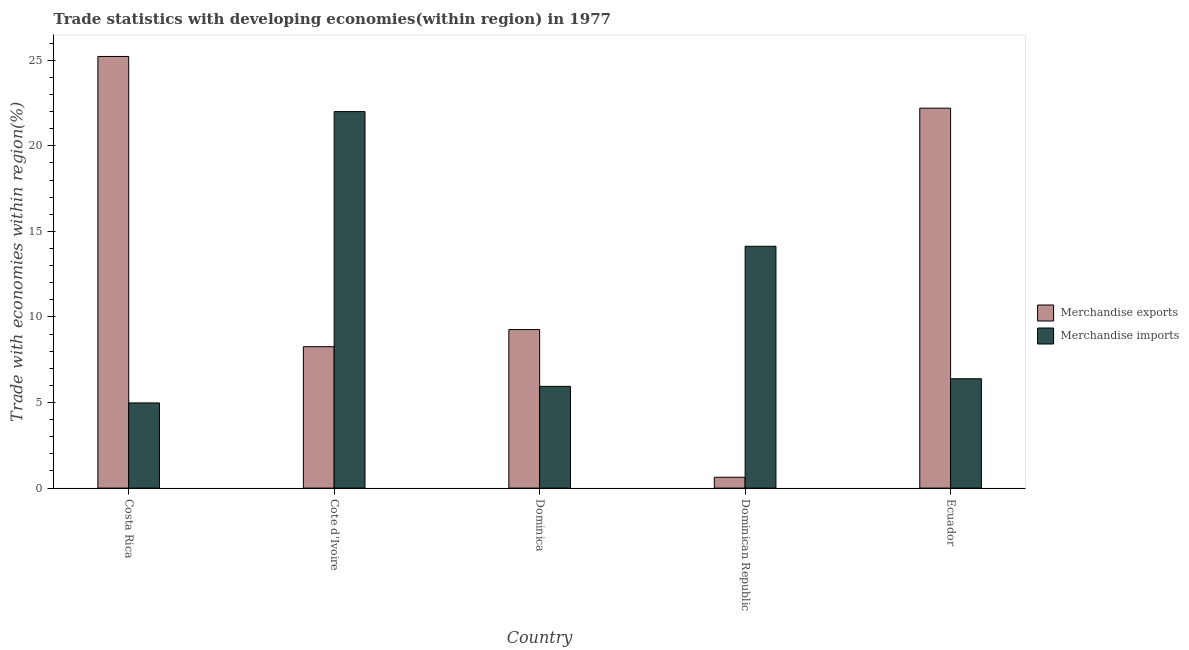Are the number of bars per tick equal to the number of legend labels?
Keep it short and to the point. Yes. Are the number of bars on each tick of the X-axis equal?
Offer a terse response. Yes. What is the label of the 3rd group of bars from the left?
Ensure brevity in your answer.  Dominica. In how many cases, is the number of bars for a given country not equal to the number of legend labels?
Your answer should be compact. 0. What is the merchandise exports in Cote d'Ivoire?
Your response must be concise. 8.26. Across all countries, what is the maximum merchandise exports?
Ensure brevity in your answer.  25.23. Across all countries, what is the minimum merchandise exports?
Keep it short and to the point. 0.63. In which country was the merchandise exports maximum?
Ensure brevity in your answer.  Costa Rica. In which country was the merchandise exports minimum?
Your response must be concise. Dominican Republic. What is the total merchandise imports in the graph?
Your answer should be compact. 53.45. What is the difference between the merchandise imports in Costa Rica and that in Cote d'Ivoire?
Give a very brief answer. -17.03. What is the difference between the merchandise exports in Cote d'Ivoire and the merchandise imports in Dominican Republic?
Offer a terse response. -5.87. What is the average merchandise imports per country?
Offer a very short reply. 10.69. What is the difference between the merchandise imports and merchandise exports in Cote d'Ivoire?
Provide a succinct answer. 13.74. In how many countries, is the merchandise exports greater than 20 %?
Your response must be concise. 2. What is the ratio of the merchandise imports in Costa Rica to that in Cote d'Ivoire?
Your answer should be compact. 0.23. Is the merchandise exports in Costa Rica less than that in Dominican Republic?
Your response must be concise. No. What is the difference between the highest and the second highest merchandise imports?
Make the answer very short. 7.87. What is the difference between the highest and the lowest merchandise exports?
Your answer should be very brief. 24.59. What does the 1st bar from the left in Dominica represents?
Make the answer very short. Merchandise exports. What does the 2nd bar from the right in Dominica represents?
Ensure brevity in your answer.  Merchandise exports. How many bars are there?
Your answer should be compact. 10. Are all the bars in the graph horizontal?
Your answer should be compact. No. How many countries are there in the graph?
Make the answer very short. 5. What is the difference between two consecutive major ticks on the Y-axis?
Give a very brief answer. 5. Does the graph contain any zero values?
Provide a short and direct response. No. What is the title of the graph?
Your answer should be very brief. Trade statistics with developing economies(within region) in 1977. Does "From production" appear as one of the legend labels in the graph?
Your response must be concise. No. What is the label or title of the X-axis?
Keep it short and to the point. Country. What is the label or title of the Y-axis?
Offer a terse response. Trade with economies within region(%). What is the Trade with economies within region(%) of Merchandise exports in Costa Rica?
Provide a succinct answer. 25.23. What is the Trade with economies within region(%) of Merchandise imports in Costa Rica?
Your answer should be very brief. 4.98. What is the Trade with economies within region(%) of Merchandise exports in Cote d'Ivoire?
Give a very brief answer. 8.26. What is the Trade with economies within region(%) in Merchandise imports in Cote d'Ivoire?
Your answer should be very brief. 22. What is the Trade with economies within region(%) of Merchandise exports in Dominica?
Keep it short and to the point. 9.26. What is the Trade with economies within region(%) in Merchandise imports in Dominica?
Provide a short and direct response. 5.95. What is the Trade with economies within region(%) in Merchandise exports in Dominican Republic?
Provide a short and direct response. 0.63. What is the Trade with economies within region(%) of Merchandise imports in Dominican Republic?
Give a very brief answer. 14.13. What is the Trade with economies within region(%) in Merchandise exports in Ecuador?
Ensure brevity in your answer.  22.2. What is the Trade with economies within region(%) in Merchandise imports in Ecuador?
Keep it short and to the point. 6.39. Across all countries, what is the maximum Trade with economies within region(%) of Merchandise exports?
Provide a succinct answer. 25.23. Across all countries, what is the maximum Trade with economies within region(%) of Merchandise imports?
Offer a terse response. 22. Across all countries, what is the minimum Trade with economies within region(%) of Merchandise exports?
Your answer should be very brief. 0.63. Across all countries, what is the minimum Trade with economies within region(%) in Merchandise imports?
Your answer should be very brief. 4.98. What is the total Trade with economies within region(%) in Merchandise exports in the graph?
Provide a short and direct response. 65.59. What is the total Trade with economies within region(%) of Merchandise imports in the graph?
Offer a very short reply. 53.45. What is the difference between the Trade with economies within region(%) of Merchandise exports in Costa Rica and that in Cote d'Ivoire?
Make the answer very short. 16.96. What is the difference between the Trade with economies within region(%) of Merchandise imports in Costa Rica and that in Cote d'Ivoire?
Make the answer very short. -17.03. What is the difference between the Trade with economies within region(%) of Merchandise exports in Costa Rica and that in Dominica?
Your response must be concise. 15.96. What is the difference between the Trade with economies within region(%) in Merchandise imports in Costa Rica and that in Dominica?
Your answer should be compact. -0.97. What is the difference between the Trade with economies within region(%) in Merchandise exports in Costa Rica and that in Dominican Republic?
Your answer should be very brief. 24.59. What is the difference between the Trade with economies within region(%) in Merchandise imports in Costa Rica and that in Dominican Republic?
Offer a very short reply. -9.15. What is the difference between the Trade with economies within region(%) in Merchandise exports in Costa Rica and that in Ecuador?
Provide a short and direct response. 3.02. What is the difference between the Trade with economies within region(%) in Merchandise imports in Costa Rica and that in Ecuador?
Your answer should be compact. -1.41. What is the difference between the Trade with economies within region(%) of Merchandise exports in Cote d'Ivoire and that in Dominica?
Your answer should be compact. -1. What is the difference between the Trade with economies within region(%) in Merchandise imports in Cote d'Ivoire and that in Dominica?
Your answer should be very brief. 16.06. What is the difference between the Trade with economies within region(%) in Merchandise exports in Cote d'Ivoire and that in Dominican Republic?
Keep it short and to the point. 7.63. What is the difference between the Trade with economies within region(%) of Merchandise imports in Cote d'Ivoire and that in Dominican Republic?
Ensure brevity in your answer.  7.87. What is the difference between the Trade with economies within region(%) in Merchandise exports in Cote d'Ivoire and that in Ecuador?
Your response must be concise. -13.94. What is the difference between the Trade with economies within region(%) of Merchandise imports in Cote d'Ivoire and that in Ecuador?
Keep it short and to the point. 15.61. What is the difference between the Trade with economies within region(%) in Merchandise exports in Dominica and that in Dominican Republic?
Ensure brevity in your answer.  8.63. What is the difference between the Trade with economies within region(%) of Merchandise imports in Dominica and that in Dominican Republic?
Offer a very short reply. -8.19. What is the difference between the Trade with economies within region(%) of Merchandise exports in Dominica and that in Ecuador?
Offer a terse response. -12.94. What is the difference between the Trade with economies within region(%) in Merchandise imports in Dominica and that in Ecuador?
Provide a succinct answer. -0.44. What is the difference between the Trade with economies within region(%) of Merchandise exports in Dominican Republic and that in Ecuador?
Provide a short and direct response. -21.57. What is the difference between the Trade with economies within region(%) of Merchandise imports in Dominican Republic and that in Ecuador?
Ensure brevity in your answer.  7.74. What is the difference between the Trade with economies within region(%) in Merchandise exports in Costa Rica and the Trade with economies within region(%) in Merchandise imports in Cote d'Ivoire?
Make the answer very short. 3.22. What is the difference between the Trade with economies within region(%) of Merchandise exports in Costa Rica and the Trade with economies within region(%) of Merchandise imports in Dominica?
Offer a very short reply. 19.28. What is the difference between the Trade with economies within region(%) in Merchandise exports in Costa Rica and the Trade with economies within region(%) in Merchandise imports in Dominican Republic?
Ensure brevity in your answer.  11.09. What is the difference between the Trade with economies within region(%) of Merchandise exports in Costa Rica and the Trade with economies within region(%) of Merchandise imports in Ecuador?
Your answer should be compact. 18.84. What is the difference between the Trade with economies within region(%) of Merchandise exports in Cote d'Ivoire and the Trade with economies within region(%) of Merchandise imports in Dominica?
Give a very brief answer. 2.32. What is the difference between the Trade with economies within region(%) of Merchandise exports in Cote d'Ivoire and the Trade with economies within region(%) of Merchandise imports in Dominican Republic?
Your answer should be very brief. -5.87. What is the difference between the Trade with economies within region(%) in Merchandise exports in Cote d'Ivoire and the Trade with economies within region(%) in Merchandise imports in Ecuador?
Make the answer very short. 1.88. What is the difference between the Trade with economies within region(%) of Merchandise exports in Dominica and the Trade with economies within region(%) of Merchandise imports in Dominican Republic?
Offer a very short reply. -4.87. What is the difference between the Trade with economies within region(%) of Merchandise exports in Dominica and the Trade with economies within region(%) of Merchandise imports in Ecuador?
Provide a short and direct response. 2.88. What is the difference between the Trade with economies within region(%) in Merchandise exports in Dominican Republic and the Trade with economies within region(%) in Merchandise imports in Ecuador?
Give a very brief answer. -5.76. What is the average Trade with economies within region(%) of Merchandise exports per country?
Make the answer very short. 13.12. What is the average Trade with economies within region(%) in Merchandise imports per country?
Your response must be concise. 10.69. What is the difference between the Trade with economies within region(%) of Merchandise exports and Trade with economies within region(%) of Merchandise imports in Costa Rica?
Make the answer very short. 20.25. What is the difference between the Trade with economies within region(%) in Merchandise exports and Trade with economies within region(%) in Merchandise imports in Cote d'Ivoire?
Offer a terse response. -13.74. What is the difference between the Trade with economies within region(%) of Merchandise exports and Trade with economies within region(%) of Merchandise imports in Dominica?
Provide a short and direct response. 3.32. What is the difference between the Trade with economies within region(%) of Merchandise exports and Trade with economies within region(%) of Merchandise imports in Dominican Republic?
Your answer should be very brief. -13.5. What is the difference between the Trade with economies within region(%) in Merchandise exports and Trade with economies within region(%) in Merchandise imports in Ecuador?
Provide a succinct answer. 15.81. What is the ratio of the Trade with economies within region(%) of Merchandise exports in Costa Rica to that in Cote d'Ivoire?
Your answer should be very brief. 3.05. What is the ratio of the Trade with economies within region(%) of Merchandise imports in Costa Rica to that in Cote d'Ivoire?
Give a very brief answer. 0.23. What is the ratio of the Trade with economies within region(%) in Merchandise exports in Costa Rica to that in Dominica?
Ensure brevity in your answer.  2.72. What is the ratio of the Trade with economies within region(%) in Merchandise imports in Costa Rica to that in Dominica?
Keep it short and to the point. 0.84. What is the ratio of the Trade with economies within region(%) in Merchandise exports in Costa Rica to that in Dominican Republic?
Offer a very short reply. 39.81. What is the ratio of the Trade with economies within region(%) in Merchandise imports in Costa Rica to that in Dominican Republic?
Provide a short and direct response. 0.35. What is the ratio of the Trade with economies within region(%) in Merchandise exports in Costa Rica to that in Ecuador?
Make the answer very short. 1.14. What is the ratio of the Trade with economies within region(%) in Merchandise imports in Costa Rica to that in Ecuador?
Give a very brief answer. 0.78. What is the ratio of the Trade with economies within region(%) of Merchandise exports in Cote d'Ivoire to that in Dominica?
Ensure brevity in your answer.  0.89. What is the ratio of the Trade with economies within region(%) of Merchandise imports in Cote d'Ivoire to that in Dominica?
Offer a terse response. 3.7. What is the ratio of the Trade with economies within region(%) in Merchandise exports in Cote d'Ivoire to that in Dominican Republic?
Your response must be concise. 13.04. What is the ratio of the Trade with economies within region(%) in Merchandise imports in Cote d'Ivoire to that in Dominican Republic?
Keep it short and to the point. 1.56. What is the ratio of the Trade with economies within region(%) of Merchandise exports in Cote d'Ivoire to that in Ecuador?
Your response must be concise. 0.37. What is the ratio of the Trade with economies within region(%) of Merchandise imports in Cote d'Ivoire to that in Ecuador?
Make the answer very short. 3.44. What is the ratio of the Trade with economies within region(%) of Merchandise exports in Dominica to that in Dominican Republic?
Offer a terse response. 14.62. What is the ratio of the Trade with economies within region(%) in Merchandise imports in Dominica to that in Dominican Republic?
Make the answer very short. 0.42. What is the ratio of the Trade with economies within region(%) of Merchandise exports in Dominica to that in Ecuador?
Your response must be concise. 0.42. What is the ratio of the Trade with economies within region(%) of Merchandise imports in Dominica to that in Ecuador?
Provide a succinct answer. 0.93. What is the ratio of the Trade with economies within region(%) in Merchandise exports in Dominican Republic to that in Ecuador?
Keep it short and to the point. 0.03. What is the ratio of the Trade with economies within region(%) in Merchandise imports in Dominican Republic to that in Ecuador?
Make the answer very short. 2.21. What is the difference between the highest and the second highest Trade with economies within region(%) in Merchandise exports?
Provide a succinct answer. 3.02. What is the difference between the highest and the second highest Trade with economies within region(%) of Merchandise imports?
Offer a very short reply. 7.87. What is the difference between the highest and the lowest Trade with economies within region(%) in Merchandise exports?
Provide a succinct answer. 24.59. What is the difference between the highest and the lowest Trade with economies within region(%) in Merchandise imports?
Ensure brevity in your answer.  17.03. 